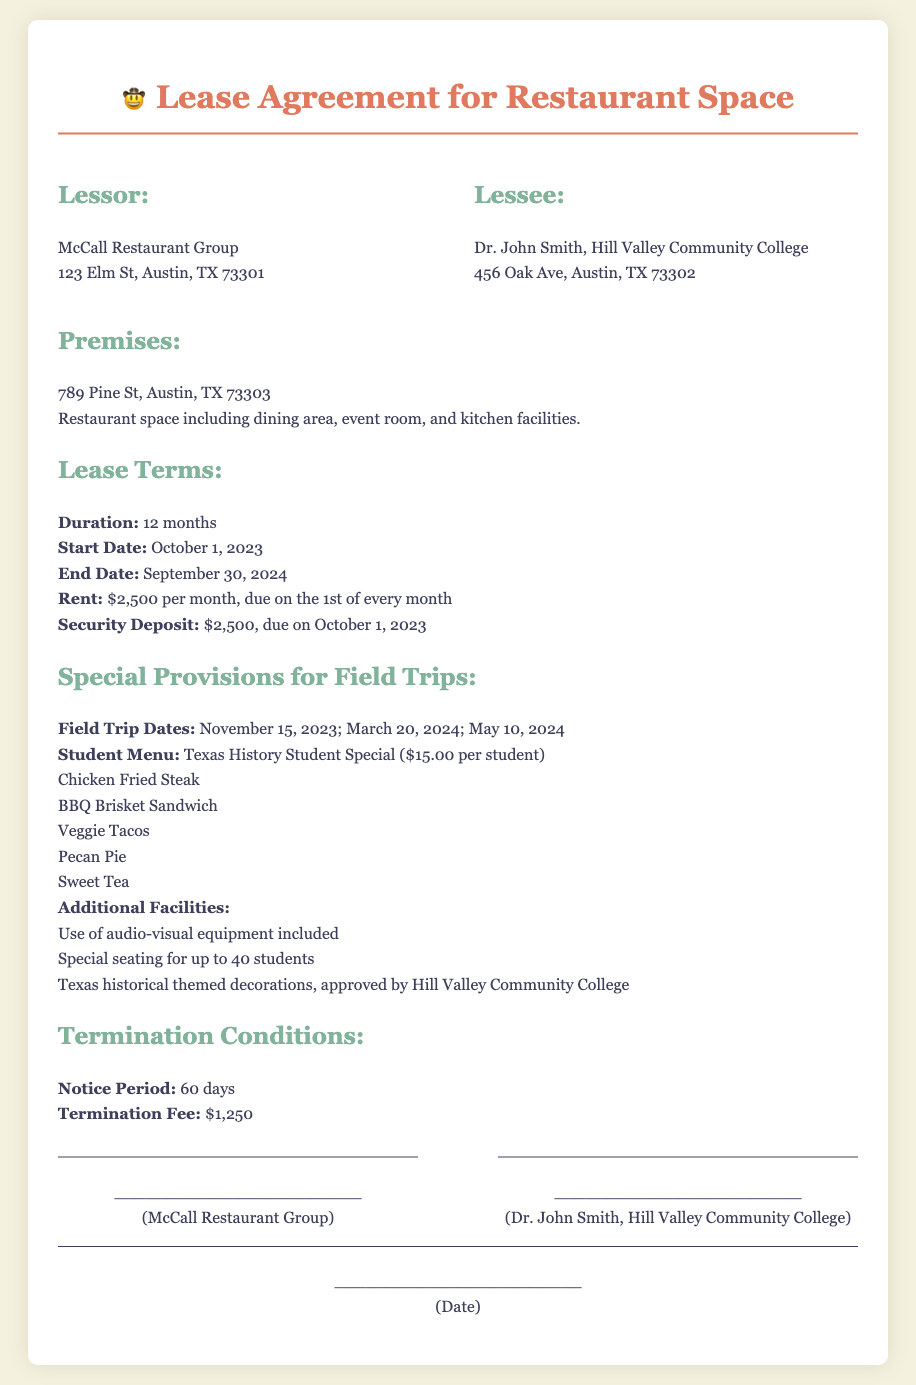What is the name of the lessor? The lessor is identified as McCall Restaurant Group in the document.
Answer: McCall Restaurant Group What is the monthly rent amount? The document states that the rent is $2,500 per month.
Answer: $2,500 What is the start date of the lease? The start date is specified as October 1, 2023.
Answer: October 1, 2023 How many students can be seated? The document indicates that there is special seating for up to 40 students.
Answer: 40 students What is included in the special student menu? The student menu includes Chicken Fried Steak, BBQ Brisket Sandwich, Veggie Tacos, Pecan Pie, and Sweet Tea according to the provisions.
Answer: Chicken Fried Steak, BBQ Brisket Sandwich, Veggie Tacos, Pecan Pie, Sweet Tea What is the termination fee? The termination fee specified in the lease agreement is $1,250.
Answer: $1,250 What is the notice period for termination? The document indicates a notice period of 60 days for lease termination.
Answer: 60 days When is the first field trip date? The first field trip date is listed as November 15, 2023.
Answer: November 15, 2023 